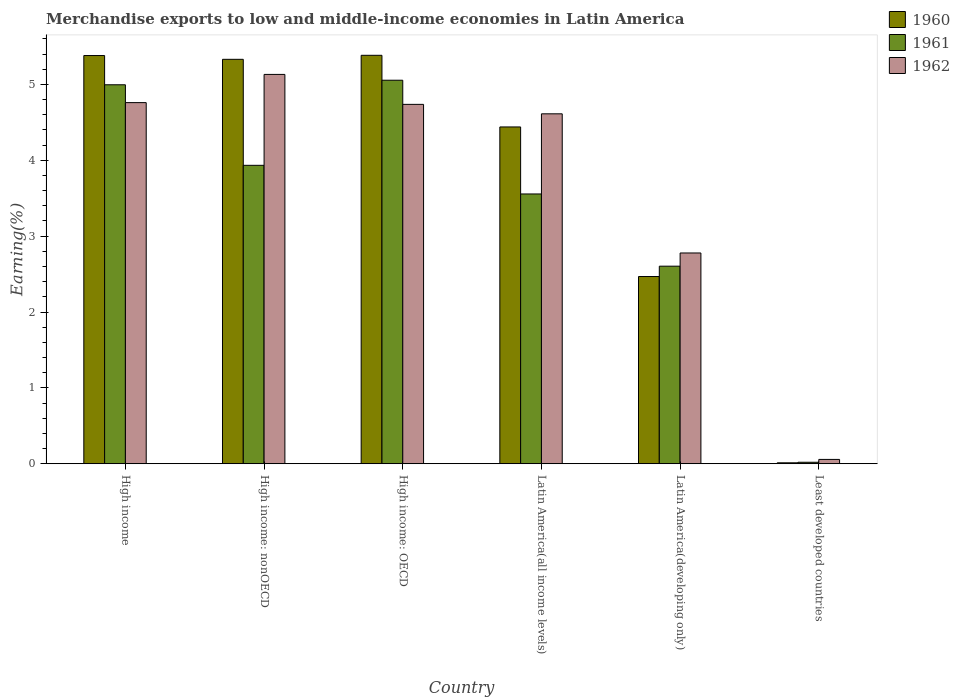How many groups of bars are there?
Keep it short and to the point. 6. How many bars are there on the 4th tick from the left?
Your answer should be very brief. 3. How many bars are there on the 2nd tick from the right?
Your answer should be compact. 3. What is the label of the 6th group of bars from the left?
Make the answer very short. Least developed countries. What is the percentage of amount earned from merchandise exports in 1962 in High income: nonOECD?
Offer a terse response. 5.13. Across all countries, what is the maximum percentage of amount earned from merchandise exports in 1960?
Ensure brevity in your answer.  5.38. Across all countries, what is the minimum percentage of amount earned from merchandise exports in 1962?
Provide a short and direct response. 0.06. In which country was the percentage of amount earned from merchandise exports in 1961 maximum?
Provide a short and direct response. High income: OECD. In which country was the percentage of amount earned from merchandise exports in 1961 minimum?
Provide a succinct answer. Least developed countries. What is the total percentage of amount earned from merchandise exports in 1961 in the graph?
Offer a terse response. 20.17. What is the difference between the percentage of amount earned from merchandise exports in 1960 in High income and that in High income: nonOECD?
Make the answer very short. 0.05. What is the difference between the percentage of amount earned from merchandise exports in 1960 in Latin America(all income levels) and the percentage of amount earned from merchandise exports in 1962 in Least developed countries?
Make the answer very short. 4.38. What is the average percentage of amount earned from merchandise exports in 1962 per country?
Ensure brevity in your answer.  3.68. What is the difference between the percentage of amount earned from merchandise exports of/in 1960 and percentage of amount earned from merchandise exports of/in 1961 in High income: OECD?
Give a very brief answer. 0.33. In how many countries, is the percentage of amount earned from merchandise exports in 1961 greater than 2 %?
Provide a succinct answer. 5. What is the ratio of the percentage of amount earned from merchandise exports in 1962 in High income: nonOECD to that in Latin America(developing only)?
Offer a terse response. 1.85. What is the difference between the highest and the second highest percentage of amount earned from merchandise exports in 1962?
Your answer should be very brief. -0.02. What is the difference between the highest and the lowest percentage of amount earned from merchandise exports in 1960?
Keep it short and to the point. 5.37. Are all the bars in the graph horizontal?
Your response must be concise. No. Are the values on the major ticks of Y-axis written in scientific E-notation?
Ensure brevity in your answer.  No. Does the graph contain any zero values?
Offer a terse response. No. How many legend labels are there?
Offer a terse response. 3. What is the title of the graph?
Ensure brevity in your answer.  Merchandise exports to low and middle-income economies in Latin America. What is the label or title of the X-axis?
Make the answer very short. Country. What is the label or title of the Y-axis?
Your answer should be compact. Earning(%). What is the Earning(%) in 1960 in High income?
Keep it short and to the point. 5.38. What is the Earning(%) of 1961 in High income?
Offer a terse response. 5. What is the Earning(%) in 1962 in High income?
Provide a short and direct response. 4.76. What is the Earning(%) in 1960 in High income: nonOECD?
Ensure brevity in your answer.  5.33. What is the Earning(%) in 1961 in High income: nonOECD?
Keep it short and to the point. 3.93. What is the Earning(%) of 1962 in High income: nonOECD?
Give a very brief answer. 5.13. What is the Earning(%) in 1960 in High income: OECD?
Offer a terse response. 5.38. What is the Earning(%) of 1961 in High income: OECD?
Offer a very short reply. 5.06. What is the Earning(%) of 1962 in High income: OECD?
Your answer should be very brief. 4.74. What is the Earning(%) in 1960 in Latin America(all income levels)?
Make the answer very short. 4.44. What is the Earning(%) in 1961 in Latin America(all income levels)?
Give a very brief answer. 3.56. What is the Earning(%) in 1962 in Latin America(all income levels)?
Keep it short and to the point. 4.61. What is the Earning(%) in 1960 in Latin America(developing only)?
Give a very brief answer. 2.47. What is the Earning(%) in 1961 in Latin America(developing only)?
Your response must be concise. 2.6. What is the Earning(%) of 1962 in Latin America(developing only)?
Ensure brevity in your answer.  2.78. What is the Earning(%) in 1960 in Least developed countries?
Offer a very short reply. 0.01. What is the Earning(%) of 1961 in Least developed countries?
Offer a very short reply. 0.02. What is the Earning(%) in 1962 in Least developed countries?
Your answer should be very brief. 0.06. Across all countries, what is the maximum Earning(%) in 1960?
Make the answer very short. 5.38. Across all countries, what is the maximum Earning(%) in 1961?
Make the answer very short. 5.06. Across all countries, what is the maximum Earning(%) of 1962?
Provide a short and direct response. 5.13. Across all countries, what is the minimum Earning(%) in 1960?
Ensure brevity in your answer.  0.01. Across all countries, what is the minimum Earning(%) of 1961?
Offer a terse response. 0.02. Across all countries, what is the minimum Earning(%) in 1962?
Your answer should be compact. 0.06. What is the total Earning(%) in 1960 in the graph?
Give a very brief answer. 23.02. What is the total Earning(%) of 1961 in the graph?
Make the answer very short. 20.17. What is the total Earning(%) in 1962 in the graph?
Make the answer very short. 22.08. What is the difference between the Earning(%) in 1960 in High income and that in High income: nonOECD?
Make the answer very short. 0.05. What is the difference between the Earning(%) of 1961 in High income and that in High income: nonOECD?
Keep it short and to the point. 1.06. What is the difference between the Earning(%) in 1962 in High income and that in High income: nonOECD?
Offer a very short reply. -0.37. What is the difference between the Earning(%) in 1960 in High income and that in High income: OECD?
Provide a short and direct response. -0. What is the difference between the Earning(%) in 1961 in High income and that in High income: OECD?
Your response must be concise. -0.06. What is the difference between the Earning(%) of 1962 in High income and that in High income: OECD?
Make the answer very short. 0.02. What is the difference between the Earning(%) of 1960 in High income and that in Latin America(all income levels)?
Your answer should be very brief. 0.94. What is the difference between the Earning(%) of 1961 in High income and that in Latin America(all income levels)?
Give a very brief answer. 1.44. What is the difference between the Earning(%) of 1962 in High income and that in Latin America(all income levels)?
Ensure brevity in your answer.  0.15. What is the difference between the Earning(%) of 1960 in High income and that in Latin America(developing only)?
Provide a succinct answer. 2.91. What is the difference between the Earning(%) in 1961 in High income and that in Latin America(developing only)?
Your answer should be compact. 2.39. What is the difference between the Earning(%) of 1962 in High income and that in Latin America(developing only)?
Ensure brevity in your answer.  1.98. What is the difference between the Earning(%) of 1960 in High income and that in Least developed countries?
Give a very brief answer. 5.37. What is the difference between the Earning(%) of 1961 in High income and that in Least developed countries?
Your answer should be very brief. 4.98. What is the difference between the Earning(%) of 1962 in High income and that in Least developed countries?
Your answer should be compact. 4.7. What is the difference between the Earning(%) of 1960 in High income: nonOECD and that in High income: OECD?
Offer a very short reply. -0.05. What is the difference between the Earning(%) of 1961 in High income: nonOECD and that in High income: OECD?
Give a very brief answer. -1.12. What is the difference between the Earning(%) of 1962 in High income: nonOECD and that in High income: OECD?
Your answer should be very brief. 0.39. What is the difference between the Earning(%) of 1960 in High income: nonOECD and that in Latin America(all income levels)?
Keep it short and to the point. 0.89. What is the difference between the Earning(%) in 1961 in High income: nonOECD and that in Latin America(all income levels)?
Make the answer very short. 0.38. What is the difference between the Earning(%) of 1962 in High income: nonOECD and that in Latin America(all income levels)?
Offer a terse response. 0.52. What is the difference between the Earning(%) of 1960 in High income: nonOECD and that in Latin America(developing only)?
Make the answer very short. 2.86. What is the difference between the Earning(%) of 1961 in High income: nonOECD and that in Latin America(developing only)?
Provide a succinct answer. 1.33. What is the difference between the Earning(%) of 1962 in High income: nonOECD and that in Latin America(developing only)?
Your response must be concise. 2.35. What is the difference between the Earning(%) in 1960 in High income: nonOECD and that in Least developed countries?
Make the answer very short. 5.32. What is the difference between the Earning(%) of 1961 in High income: nonOECD and that in Least developed countries?
Keep it short and to the point. 3.91. What is the difference between the Earning(%) of 1962 in High income: nonOECD and that in Least developed countries?
Ensure brevity in your answer.  5.08. What is the difference between the Earning(%) in 1960 in High income: OECD and that in Latin America(all income levels)?
Offer a very short reply. 0.94. What is the difference between the Earning(%) of 1961 in High income: OECD and that in Latin America(all income levels)?
Your answer should be compact. 1.5. What is the difference between the Earning(%) in 1962 in High income: OECD and that in Latin America(all income levels)?
Give a very brief answer. 0.12. What is the difference between the Earning(%) of 1960 in High income: OECD and that in Latin America(developing only)?
Your response must be concise. 2.92. What is the difference between the Earning(%) in 1961 in High income: OECD and that in Latin America(developing only)?
Provide a short and direct response. 2.45. What is the difference between the Earning(%) in 1962 in High income: OECD and that in Latin America(developing only)?
Your answer should be very brief. 1.96. What is the difference between the Earning(%) of 1960 in High income: OECD and that in Least developed countries?
Offer a very short reply. 5.37. What is the difference between the Earning(%) of 1961 in High income: OECD and that in Least developed countries?
Your answer should be very brief. 5.04. What is the difference between the Earning(%) of 1962 in High income: OECD and that in Least developed countries?
Provide a succinct answer. 4.68. What is the difference between the Earning(%) in 1960 in Latin America(all income levels) and that in Latin America(developing only)?
Give a very brief answer. 1.97. What is the difference between the Earning(%) of 1962 in Latin America(all income levels) and that in Latin America(developing only)?
Ensure brevity in your answer.  1.83. What is the difference between the Earning(%) of 1960 in Latin America(all income levels) and that in Least developed countries?
Offer a terse response. 4.43. What is the difference between the Earning(%) of 1961 in Latin America(all income levels) and that in Least developed countries?
Provide a succinct answer. 3.54. What is the difference between the Earning(%) of 1962 in Latin America(all income levels) and that in Least developed countries?
Make the answer very short. 4.56. What is the difference between the Earning(%) in 1960 in Latin America(developing only) and that in Least developed countries?
Give a very brief answer. 2.46. What is the difference between the Earning(%) of 1961 in Latin America(developing only) and that in Least developed countries?
Your response must be concise. 2.58. What is the difference between the Earning(%) of 1962 in Latin America(developing only) and that in Least developed countries?
Make the answer very short. 2.72. What is the difference between the Earning(%) in 1960 in High income and the Earning(%) in 1961 in High income: nonOECD?
Provide a short and direct response. 1.45. What is the difference between the Earning(%) in 1960 in High income and the Earning(%) in 1962 in High income: nonOECD?
Give a very brief answer. 0.25. What is the difference between the Earning(%) of 1961 in High income and the Earning(%) of 1962 in High income: nonOECD?
Make the answer very short. -0.14. What is the difference between the Earning(%) in 1960 in High income and the Earning(%) in 1961 in High income: OECD?
Your answer should be very brief. 0.33. What is the difference between the Earning(%) of 1960 in High income and the Earning(%) of 1962 in High income: OECD?
Offer a very short reply. 0.64. What is the difference between the Earning(%) in 1961 in High income and the Earning(%) in 1962 in High income: OECD?
Give a very brief answer. 0.26. What is the difference between the Earning(%) of 1960 in High income and the Earning(%) of 1961 in Latin America(all income levels)?
Keep it short and to the point. 1.82. What is the difference between the Earning(%) of 1960 in High income and the Earning(%) of 1962 in Latin America(all income levels)?
Give a very brief answer. 0.77. What is the difference between the Earning(%) of 1961 in High income and the Earning(%) of 1962 in Latin America(all income levels)?
Keep it short and to the point. 0.38. What is the difference between the Earning(%) of 1960 in High income and the Earning(%) of 1961 in Latin America(developing only)?
Keep it short and to the point. 2.78. What is the difference between the Earning(%) of 1960 in High income and the Earning(%) of 1962 in Latin America(developing only)?
Keep it short and to the point. 2.6. What is the difference between the Earning(%) of 1961 in High income and the Earning(%) of 1962 in Latin America(developing only)?
Offer a terse response. 2.22. What is the difference between the Earning(%) of 1960 in High income and the Earning(%) of 1961 in Least developed countries?
Provide a short and direct response. 5.36. What is the difference between the Earning(%) of 1960 in High income and the Earning(%) of 1962 in Least developed countries?
Provide a short and direct response. 5.32. What is the difference between the Earning(%) of 1961 in High income and the Earning(%) of 1962 in Least developed countries?
Provide a succinct answer. 4.94. What is the difference between the Earning(%) of 1960 in High income: nonOECD and the Earning(%) of 1961 in High income: OECD?
Give a very brief answer. 0.28. What is the difference between the Earning(%) in 1960 in High income: nonOECD and the Earning(%) in 1962 in High income: OECD?
Provide a succinct answer. 0.59. What is the difference between the Earning(%) in 1961 in High income: nonOECD and the Earning(%) in 1962 in High income: OECD?
Offer a very short reply. -0.8. What is the difference between the Earning(%) of 1960 in High income: nonOECD and the Earning(%) of 1961 in Latin America(all income levels)?
Your answer should be compact. 1.77. What is the difference between the Earning(%) in 1960 in High income: nonOECD and the Earning(%) in 1962 in Latin America(all income levels)?
Your answer should be compact. 0.72. What is the difference between the Earning(%) of 1961 in High income: nonOECD and the Earning(%) of 1962 in Latin America(all income levels)?
Provide a succinct answer. -0.68. What is the difference between the Earning(%) of 1960 in High income: nonOECD and the Earning(%) of 1961 in Latin America(developing only)?
Your response must be concise. 2.73. What is the difference between the Earning(%) of 1960 in High income: nonOECD and the Earning(%) of 1962 in Latin America(developing only)?
Give a very brief answer. 2.55. What is the difference between the Earning(%) of 1961 in High income: nonOECD and the Earning(%) of 1962 in Latin America(developing only)?
Offer a very short reply. 1.16. What is the difference between the Earning(%) in 1960 in High income: nonOECD and the Earning(%) in 1961 in Least developed countries?
Offer a terse response. 5.31. What is the difference between the Earning(%) in 1960 in High income: nonOECD and the Earning(%) in 1962 in Least developed countries?
Provide a short and direct response. 5.27. What is the difference between the Earning(%) in 1961 in High income: nonOECD and the Earning(%) in 1962 in Least developed countries?
Make the answer very short. 3.88. What is the difference between the Earning(%) in 1960 in High income: OECD and the Earning(%) in 1961 in Latin America(all income levels)?
Offer a terse response. 1.83. What is the difference between the Earning(%) of 1960 in High income: OECD and the Earning(%) of 1962 in Latin America(all income levels)?
Ensure brevity in your answer.  0.77. What is the difference between the Earning(%) of 1961 in High income: OECD and the Earning(%) of 1962 in Latin America(all income levels)?
Offer a very short reply. 0.44. What is the difference between the Earning(%) in 1960 in High income: OECD and the Earning(%) in 1961 in Latin America(developing only)?
Make the answer very short. 2.78. What is the difference between the Earning(%) in 1960 in High income: OECD and the Earning(%) in 1962 in Latin America(developing only)?
Make the answer very short. 2.61. What is the difference between the Earning(%) in 1961 in High income: OECD and the Earning(%) in 1962 in Latin America(developing only)?
Give a very brief answer. 2.28. What is the difference between the Earning(%) in 1960 in High income: OECD and the Earning(%) in 1961 in Least developed countries?
Offer a terse response. 5.36. What is the difference between the Earning(%) in 1960 in High income: OECD and the Earning(%) in 1962 in Least developed countries?
Give a very brief answer. 5.33. What is the difference between the Earning(%) of 1961 in High income: OECD and the Earning(%) of 1962 in Least developed countries?
Give a very brief answer. 5. What is the difference between the Earning(%) of 1960 in Latin America(all income levels) and the Earning(%) of 1961 in Latin America(developing only)?
Provide a succinct answer. 1.84. What is the difference between the Earning(%) of 1960 in Latin America(all income levels) and the Earning(%) of 1962 in Latin America(developing only)?
Your response must be concise. 1.66. What is the difference between the Earning(%) in 1961 in Latin America(all income levels) and the Earning(%) in 1962 in Latin America(developing only)?
Provide a short and direct response. 0.78. What is the difference between the Earning(%) in 1960 in Latin America(all income levels) and the Earning(%) in 1961 in Least developed countries?
Offer a very short reply. 4.42. What is the difference between the Earning(%) of 1960 in Latin America(all income levels) and the Earning(%) of 1962 in Least developed countries?
Your answer should be very brief. 4.38. What is the difference between the Earning(%) in 1961 in Latin America(all income levels) and the Earning(%) in 1962 in Least developed countries?
Offer a terse response. 3.5. What is the difference between the Earning(%) of 1960 in Latin America(developing only) and the Earning(%) of 1961 in Least developed countries?
Your answer should be compact. 2.45. What is the difference between the Earning(%) of 1960 in Latin America(developing only) and the Earning(%) of 1962 in Least developed countries?
Provide a short and direct response. 2.41. What is the difference between the Earning(%) of 1961 in Latin America(developing only) and the Earning(%) of 1962 in Least developed countries?
Give a very brief answer. 2.55. What is the average Earning(%) of 1960 per country?
Your answer should be very brief. 3.84. What is the average Earning(%) in 1961 per country?
Offer a terse response. 3.36. What is the average Earning(%) of 1962 per country?
Give a very brief answer. 3.68. What is the difference between the Earning(%) of 1960 and Earning(%) of 1961 in High income?
Your response must be concise. 0.39. What is the difference between the Earning(%) of 1960 and Earning(%) of 1962 in High income?
Make the answer very short. 0.62. What is the difference between the Earning(%) in 1961 and Earning(%) in 1962 in High income?
Ensure brevity in your answer.  0.24. What is the difference between the Earning(%) of 1960 and Earning(%) of 1961 in High income: nonOECD?
Offer a very short reply. 1.4. What is the difference between the Earning(%) in 1960 and Earning(%) in 1962 in High income: nonOECD?
Keep it short and to the point. 0.2. What is the difference between the Earning(%) of 1961 and Earning(%) of 1962 in High income: nonOECD?
Your answer should be very brief. -1.2. What is the difference between the Earning(%) of 1960 and Earning(%) of 1961 in High income: OECD?
Give a very brief answer. 0.33. What is the difference between the Earning(%) in 1960 and Earning(%) in 1962 in High income: OECD?
Your answer should be compact. 0.65. What is the difference between the Earning(%) in 1961 and Earning(%) in 1962 in High income: OECD?
Your answer should be very brief. 0.32. What is the difference between the Earning(%) of 1960 and Earning(%) of 1961 in Latin America(all income levels)?
Keep it short and to the point. 0.88. What is the difference between the Earning(%) in 1960 and Earning(%) in 1962 in Latin America(all income levels)?
Your response must be concise. -0.17. What is the difference between the Earning(%) in 1961 and Earning(%) in 1962 in Latin America(all income levels)?
Your answer should be compact. -1.06. What is the difference between the Earning(%) in 1960 and Earning(%) in 1961 in Latin America(developing only)?
Offer a very short reply. -0.14. What is the difference between the Earning(%) of 1960 and Earning(%) of 1962 in Latin America(developing only)?
Make the answer very short. -0.31. What is the difference between the Earning(%) in 1961 and Earning(%) in 1962 in Latin America(developing only)?
Offer a very short reply. -0.17. What is the difference between the Earning(%) of 1960 and Earning(%) of 1961 in Least developed countries?
Offer a very short reply. -0.01. What is the difference between the Earning(%) in 1960 and Earning(%) in 1962 in Least developed countries?
Give a very brief answer. -0.04. What is the difference between the Earning(%) in 1961 and Earning(%) in 1962 in Least developed countries?
Offer a very short reply. -0.04. What is the ratio of the Earning(%) of 1960 in High income to that in High income: nonOECD?
Offer a very short reply. 1.01. What is the ratio of the Earning(%) in 1961 in High income to that in High income: nonOECD?
Keep it short and to the point. 1.27. What is the ratio of the Earning(%) in 1962 in High income to that in High income: nonOECD?
Provide a short and direct response. 0.93. What is the ratio of the Earning(%) in 1960 in High income to that in High income: OECD?
Your answer should be compact. 1. What is the ratio of the Earning(%) in 1961 in High income to that in High income: OECD?
Your response must be concise. 0.99. What is the ratio of the Earning(%) of 1962 in High income to that in High income: OECD?
Provide a short and direct response. 1. What is the ratio of the Earning(%) in 1960 in High income to that in Latin America(all income levels)?
Provide a succinct answer. 1.21. What is the ratio of the Earning(%) of 1961 in High income to that in Latin America(all income levels)?
Ensure brevity in your answer.  1.4. What is the ratio of the Earning(%) in 1962 in High income to that in Latin America(all income levels)?
Your answer should be very brief. 1.03. What is the ratio of the Earning(%) in 1960 in High income to that in Latin America(developing only)?
Provide a short and direct response. 2.18. What is the ratio of the Earning(%) in 1961 in High income to that in Latin America(developing only)?
Make the answer very short. 1.92. What is the ratio of the Earning(%) of 1962 in High income to that in Latin America(developing only)?
Your answer should be very brief. 1.71. What is the ratio of the Earning(%) of 1960 in High income to that in Least developed countries?
Ensure brevity in your answer.  435.92. What is the ratio of the Earning(%) of 1961 in High income to that in Least developed countries?
Ensure brevity in your answer.  256.06. What is the ratio of the Earning(%) in 1962 in High income to that in Least developed countries?
Offer a very short reply. 83.6. What is the ratio of the Earning(%) of 1960 in High income: nonOECD to that in High income: OECD?
Provide a short and direct response. 0.99. What is the ratio of the Earning(%) of 1961 in High income: nonOECD to that in High income: OECD?
Keep it short and to the point. 0.78. What is the ratio of the Earning(%) in 1960 in High income: nonOECD to that in Latin America(all income levels)?
Give a very brief answer. 1.2. What is the ratio of the Earning(%) in 1961 in High income: nonOECD to that in Latin America(all income levels)?
Your answer should be very brief. 1.11. What is the ratio of the Earning(%) of 1962 in High income: nonOECD to that in Latin America(all income levels)?
Ensure brevity in your answer.  1.11. What is the ratio of the Earning(%) in 1960 in High income: nonOECD to that in Latin America(developing only)?
Make the answer very short. 2.16. What is the ratio of the Earning(%) of 1961 in High income: nonOECD to that in Latin America(developing only)?
Offer a very short reply. 1.51. What is the ratio of the Earning(%) of 1962 in High income: nonOECD to that in Latin America(developing only)?
Make the answer very short. 1.85. What is the ratio of the Earning(%) of 1960 in High income: nonOECD to that in Least developed countries?
Provide a succinct answer. 431.88. What is the ratio of the Earning(%) of 1961 in High income: nonOECD to that in Least developed countries?
Keep it short and to the point. 201.64. What is the ratio of the Earning(%) in 1962 in High income: nonOECD to that in Least developed countries?
Provide a short and direct response. 90.13. What is the ratio of the Earning(%) of 1960 in High income: OECD to that in Latin America(all income levels)?
Keep it short and to the point. 1.21. What is the ratio of the Earning(%) of 1961 in High income: OECD to that in Latin America(all income levels)?
Ensure brevity in your answer.  1.42. What is the ratio of the Earning(%) in 1960 in High income: OECD to that in Latin America(developing only)?
Your answer should be compact. 2.18. What is the ratio of the Earning(%) in 1961 in High income: OECD to that in Latin America(developing only)?
Your answer should be very brief. 1.94. What is the ratio of the Earning(%) of 1962 in High income: OECD to that in Latin America(developing only)?
Offer a very short reply. 1.71. What is the ratio of the Earning(%) in 1960 in High income: OECD to that in Least developed countries?
Give a very brief answer. 436.17. What is the ratio of the Earning(%) in 1961 in High income: OECD to that in Least developed countries?
Your answer should be compact. 259.14. What is the ratio of the Earning(%) of 1962 in High income: OECD to that in Least developed countries?
Your answer should be very brief. 83.19. What is the ratio of the Earning(%) of 1960 in Latin America(all income levels) to that in Latin America(developing only)?
Your answer should be very brief. 1.8. What is the ratio of the Earning(%) of 1961 in Latin America(all income levels) to that in Latin America(developing only)?
Your answer should be compact. 1.37. What is the ratio of the Earning(%) of 1962 in Latin America(all income levels) to that in Latin America(developing only)?
Your answer should be very brief. 1.66. What is the ratio of the Earning(%) of 1960 in Latin America(all income levels) to that in Least developed countries?
Offer a very short reply. 359.66. What is the ratio of the Earning(%) in 1961 in Latin America(all income levels) to that in Least developed countries?
Make the answer very short. 182.29. What is the ratio of the Earning(%) in 1962 in Latin America(all income levels) to that in Least developed countries?
Make the answer very short. 81. What is the ratio of the Earning(%) of 1960 in Latin America(developing only) to that in Least developed countries?
Your answer should be very brief. 199.93. What is the ratio of the Earning(%) in 1961 in Latin America(developing only) to that in Least developed countries?
Ensure brevity in your answer.  133.49. What is the ratio of the Earning(%) in 1962 in Latin America(developing only) to that in Least developed countries?
Give a very brief answer. 48.79. What is the difference between the highest and the second highest Earning(%) in 1960?
Offer a terse response. 0. What is the difference between the highest and the second highest Earning(%) of 1961?
Provide a succinct answer. 0.06. What is the difference between the highest and the second highest Earning(%) in 1962?
Ensure brevity in your answer.  0.37. What is the difference between the highest and the lowest Earning(%) in 1960?
Provide a short and direct response. 5.37. What is the difference between the highest and the lowest Earning(%) of 1961?
Keep it short and to the point. 5.04. What is the difference between the highest and the lowest Earning(%) of 1962?
Make the answer very short. 5.08. 